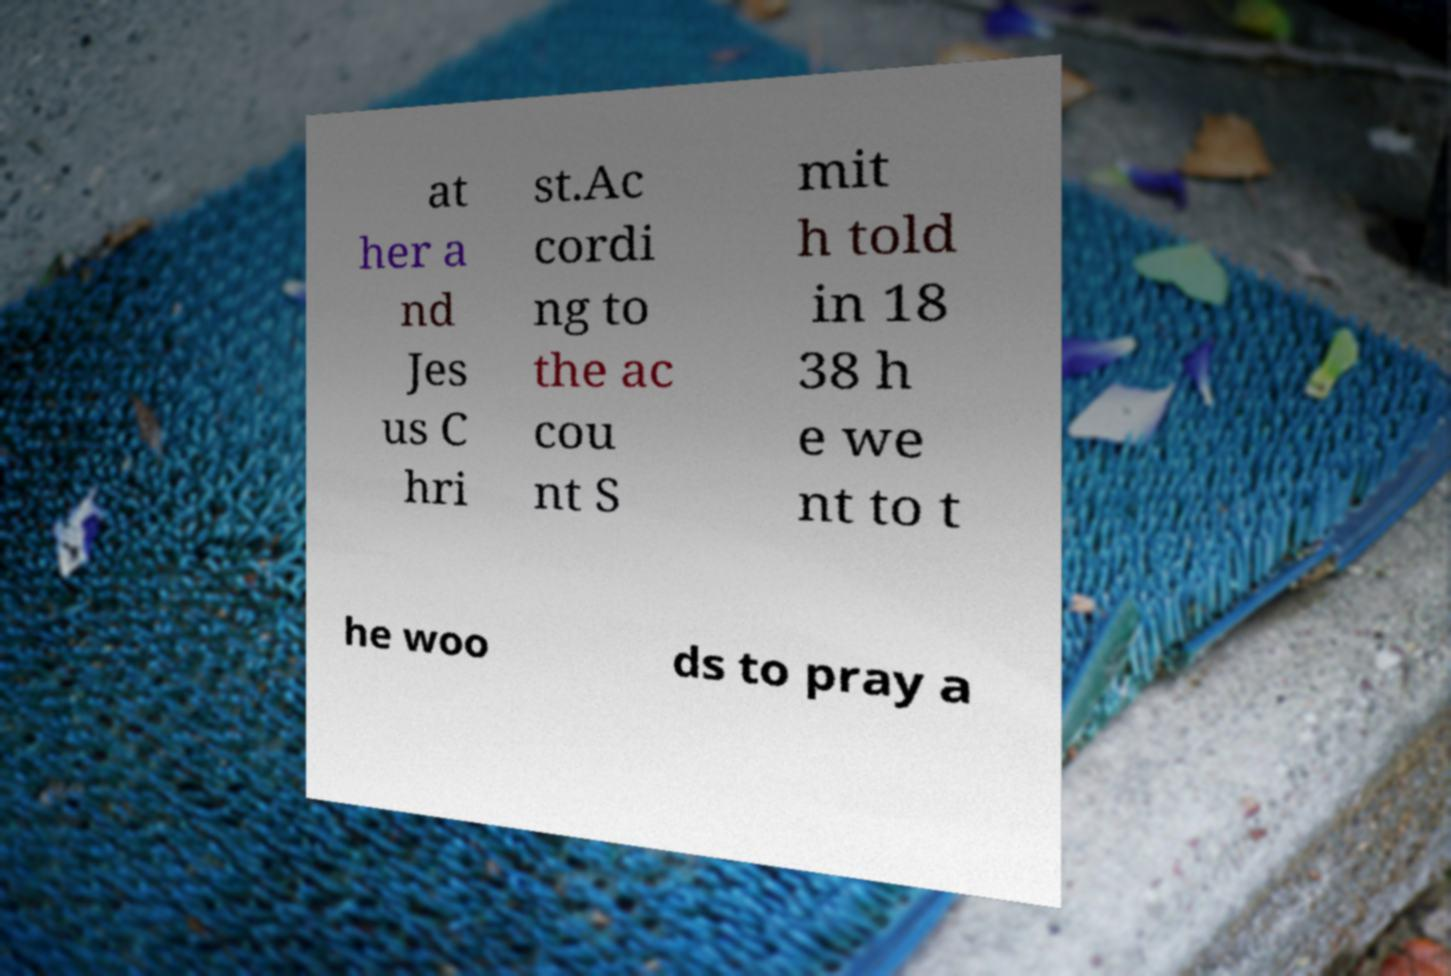For documentation purposes, I need the text within this image transcribed. Could you provide that? at her a nd Jes us C hri st.Ac cordi ng to the ac cou nt S mit h told in 18 38 h e we nt to t he woo ds to pray a 